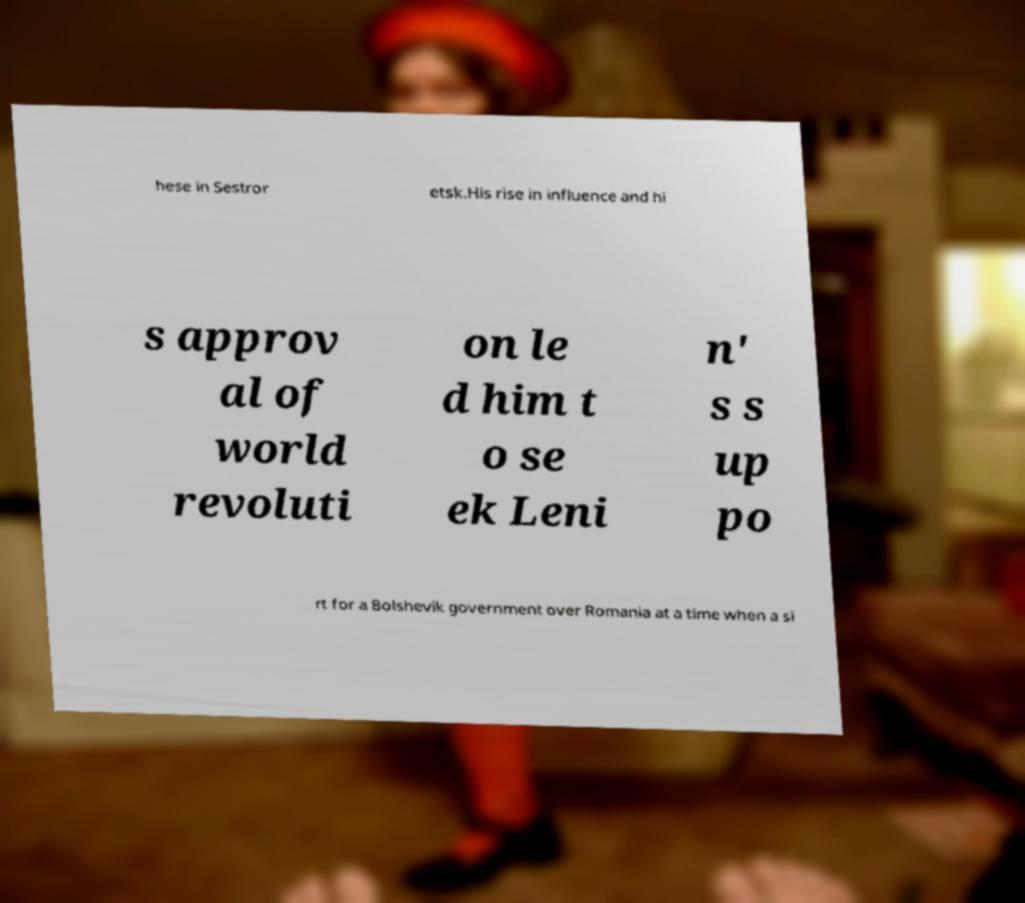Please identify and transcribe the text found in this image. hese in Sestror etsk.His rise in influence and hi s approv al of world revoluti on le d him t o se ek Leni n' s s up po rt for a Bolshevik government over Romania at a time when a si 